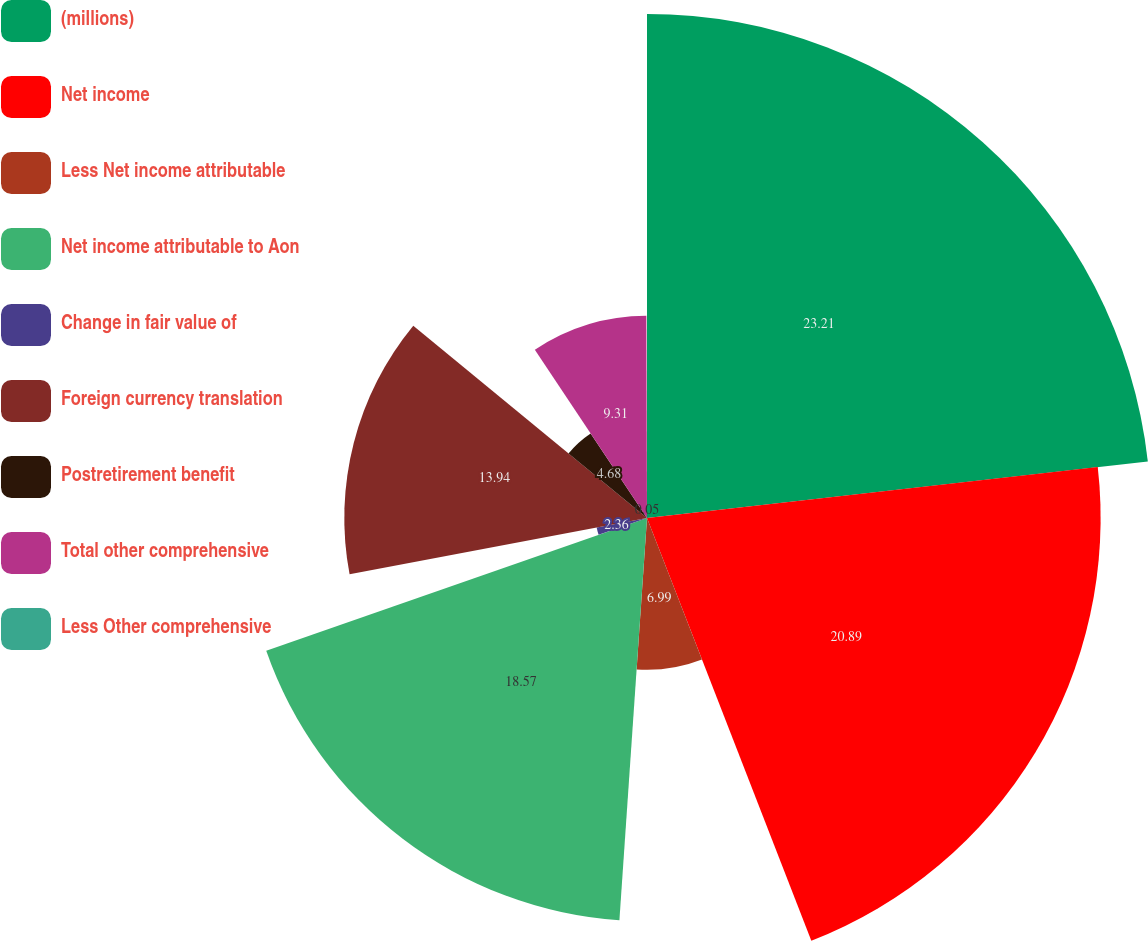<chart> <loc_0><loc_0><loc_500><loc_500><pie_chart><fcel>(millions)<fcel>Net income<fcel>Less Net income attributable<fcel>Net income attributable to Aon<fcel>Change in fair value of<fcel>Foreign currency translation<fcel>Postretirement benefit<fcel>Total other comprehensive<fcel>Less Other comprehensive<nl><fcel>23.21%<fcel>20.89%<fcel>6.99%<fcel>18.57%<fcel>2.36%<fcel>13.94%<fcel>4.68%<fcel>9.31%<fcel>0.05%<nl></chart> 